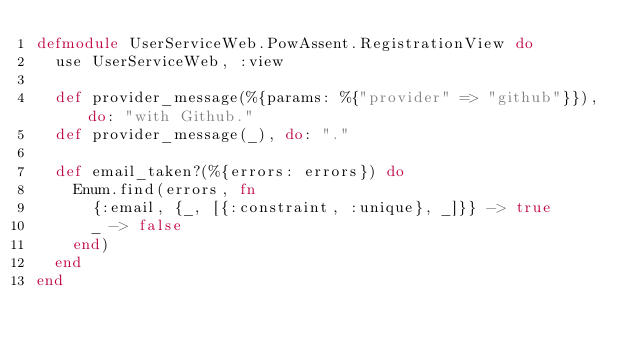Convert code to text. <code><loc_0><loc_0><loc_500><loc_500><_Elixir_>defmodule UserServiceWeb.PowAssent.RegistrationView do
  use UserServiceWeb, :view

  def provider_message(%{params: %{"provider" => "github"}}), do: "with Github."
  def provider_message(_), do: "."

  def email_taken?(%{errors: errors}) do
    Enum.find(errors, fn
      {:email, {_, [{:constraint, :unique}, _]}} -> true
      _ -> false
    end)
  end
end
</code> 